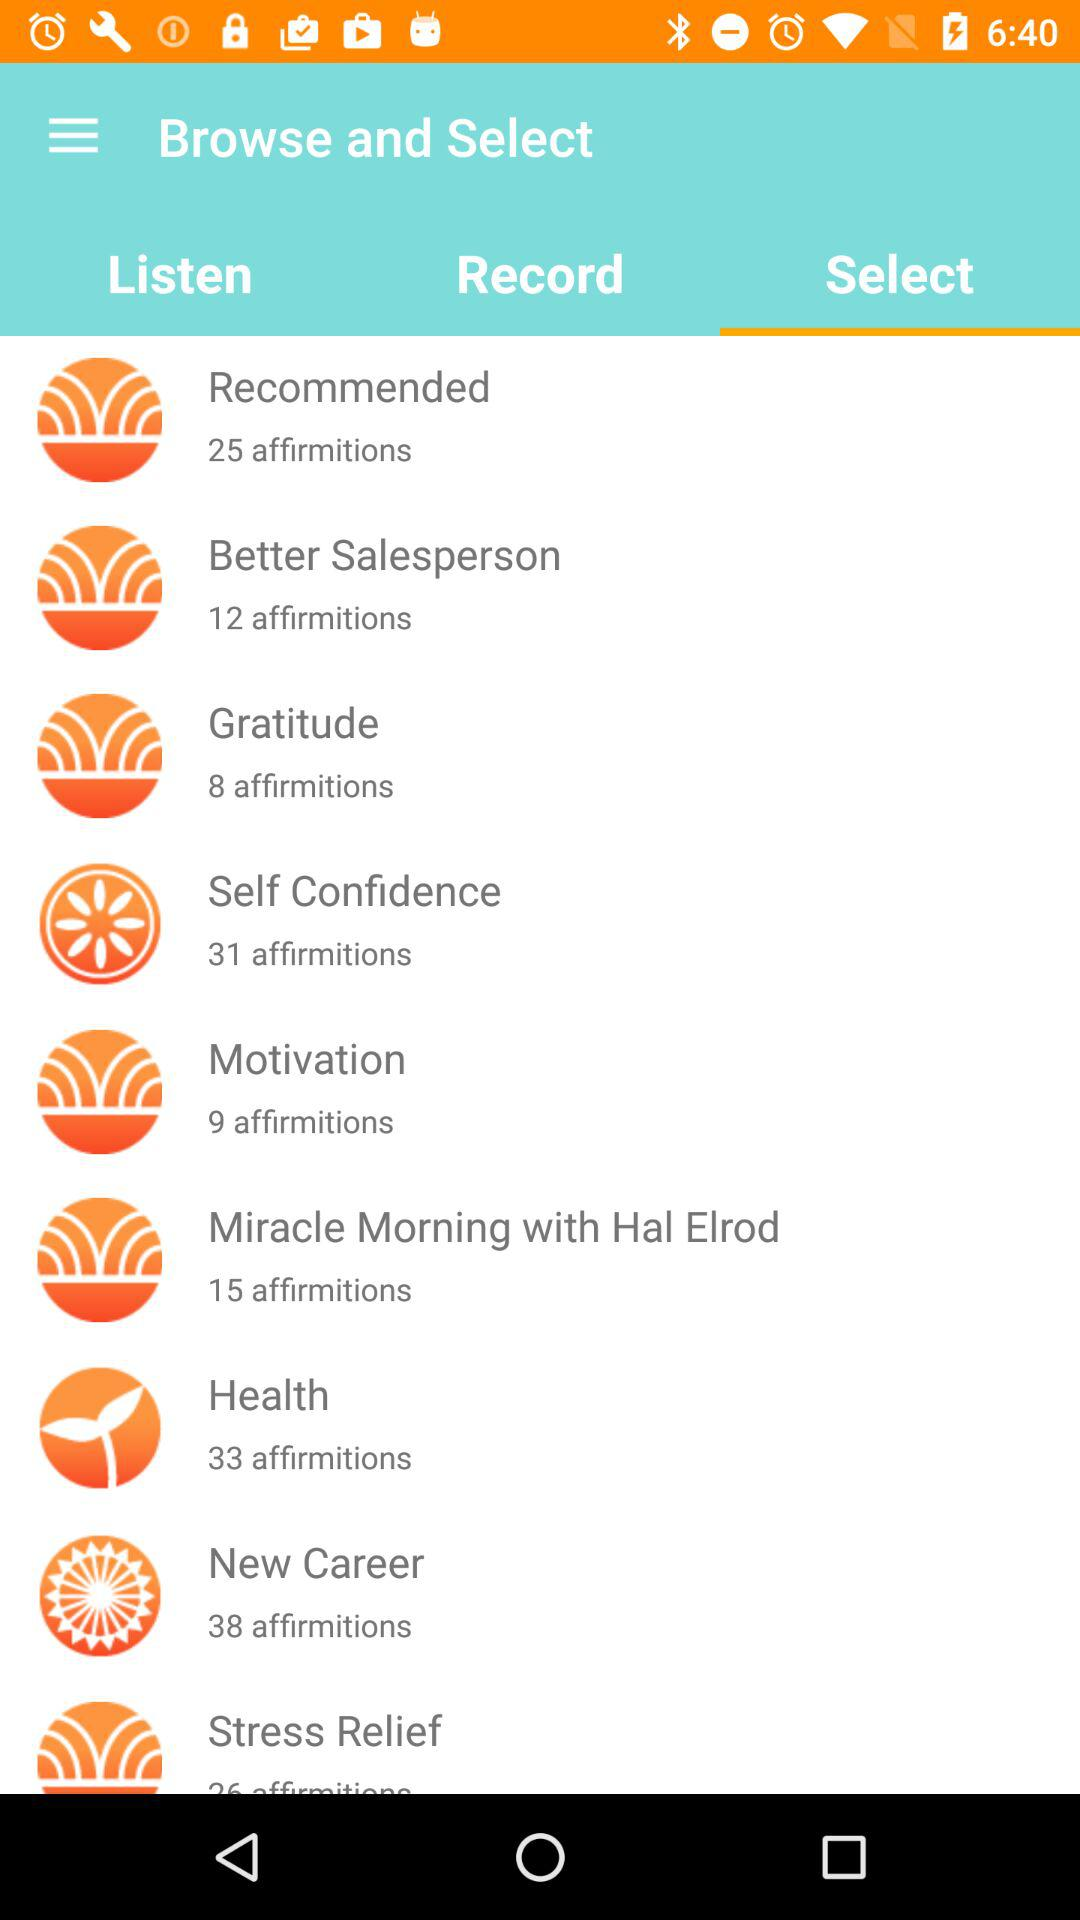Which tab is selected? The selected tab is "Select". 